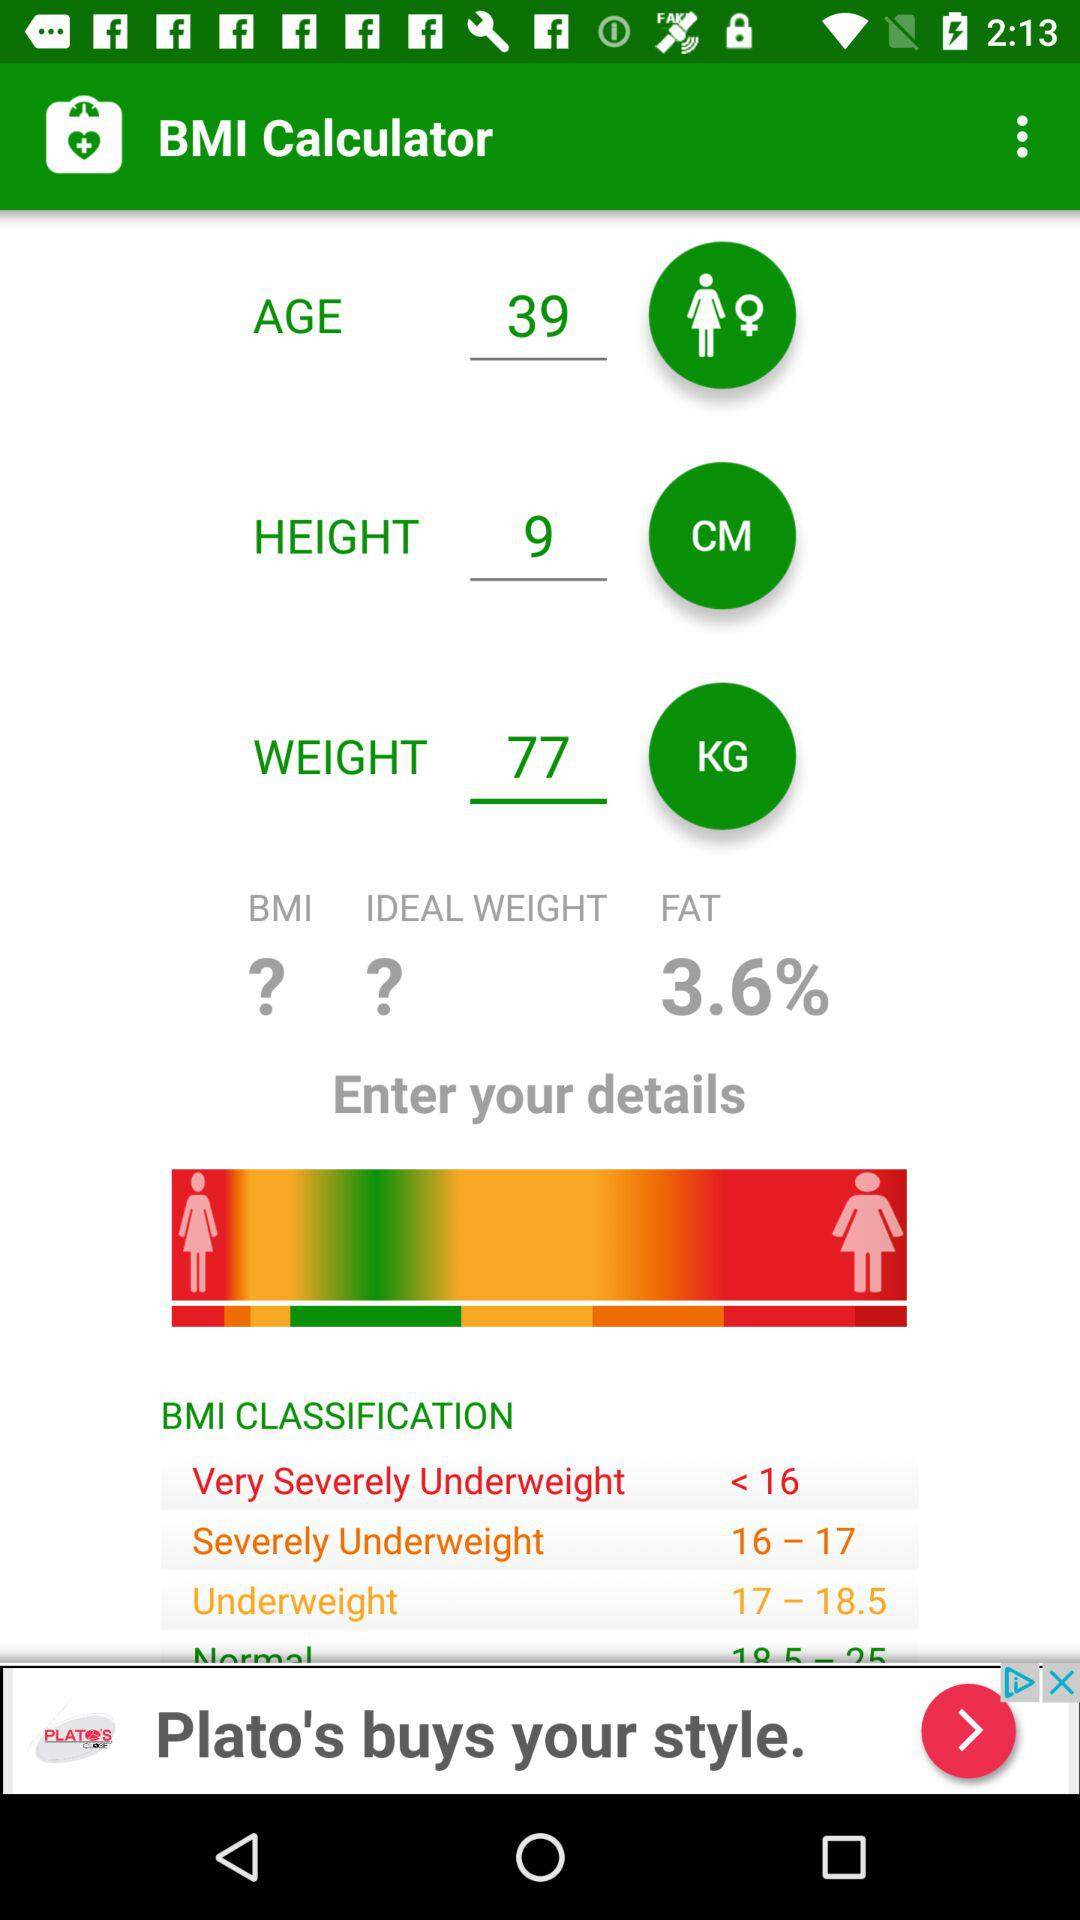What classification is there for the BMI range of 16–17? The classification is "Severely Underweight". 